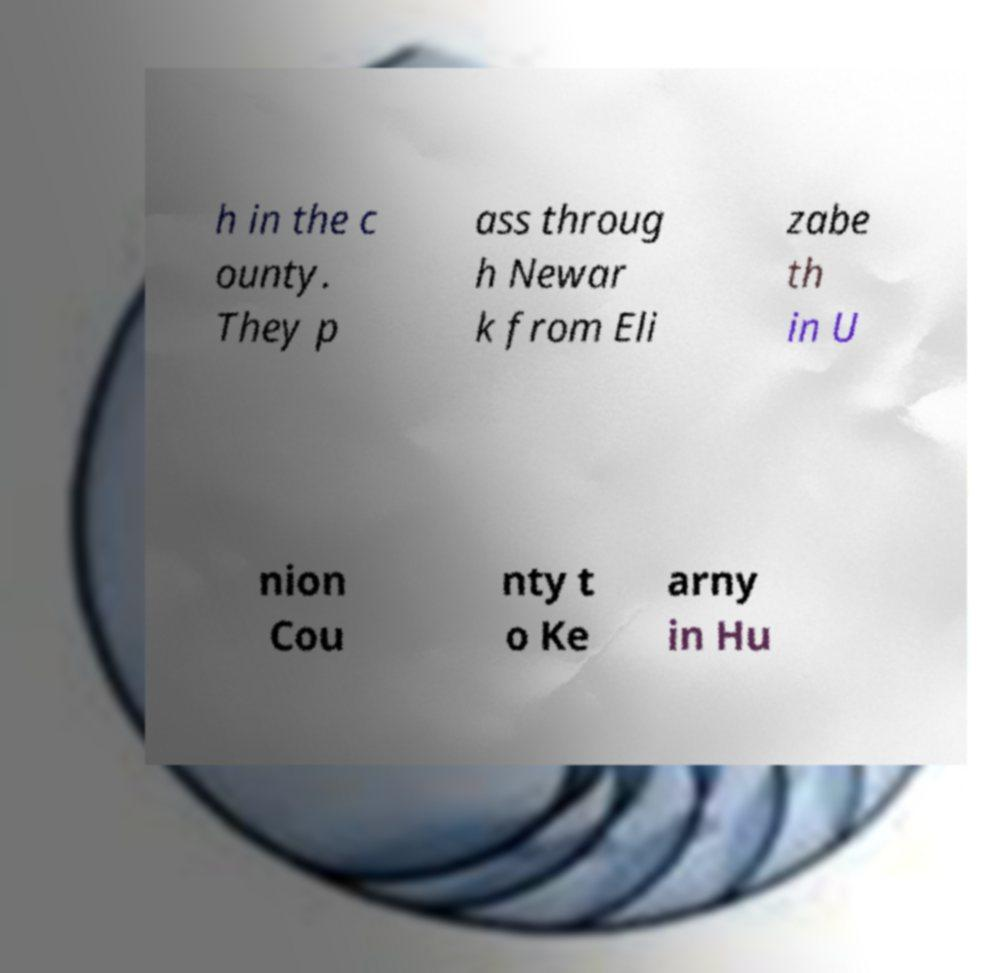Could you extract and type out the text from this image? h in the c ounty. They p ass throug h Newar k from Eli zabe th in U nion Cou nty t o Ke arny in Hu 